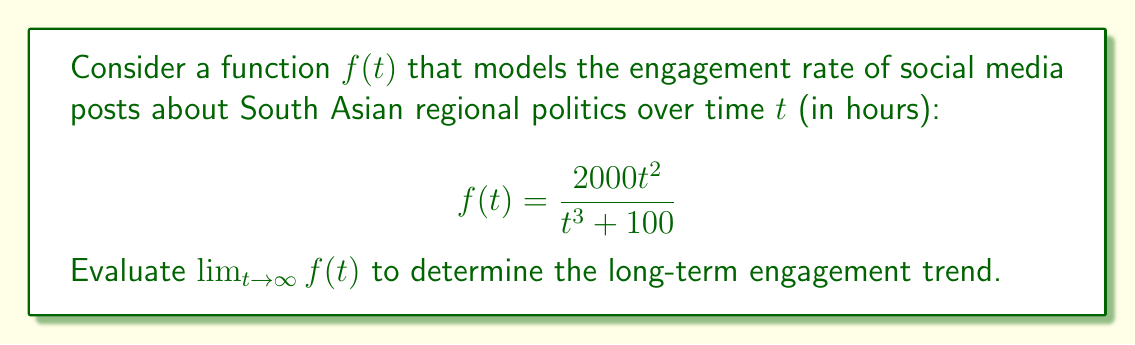Help me with this question. To evaluate this limit, we'll follow these steps:

1) First, let's consider the behavior of the numerator and denominator as $t$ approaches infinity:

   Numerator: $2000t^2$
   Denominator: $t^3 + 100$

2) Both the numerator and denominator approach infinity as $t$ approaches infinity. This is an indeterminate form of type $\frac{\infty}{\infty}$.

3) In such cases, we can use L'Hôpital's rule or divide both numerator and denominator by the highest power of $t$ in the denominator. Let's use the latter method:

   $$\lim_{t \to \infty} f(t) = \lim_{t \to \infty} \frac{2000t^2}{t^3 + 100}$$

4) Divide both numerator and denominator by $t^3$:

   $$\lim_{t \to \infty} \frac{2000t^2/t^3}{(t^3 + 100)/t^3} = \lim_{t \to \infty} \frac{2000/t}{1 + 100/t^3}$$

5) As $t$ approaches infinity:
   - $\frac{2000}{t}$ approaches 0
   - $\frac{100}{t^3}$ approaches 0

6) Therefore:

   $$\lim_{t \to \infty} \frac{2000/t}{1 + 100/t^3} = \frac{0}{1 + 0} = 0$$

This result indicates that the engagement rate approaches 0 as time goes to infinity, suggesting a decline in long-term engagement for posts about South Asian regional politics.
Answer: The limit of the function as $t$ approaches infinity is 0.

$$\lim_{t \to \infty} f(t) = 0$$ 